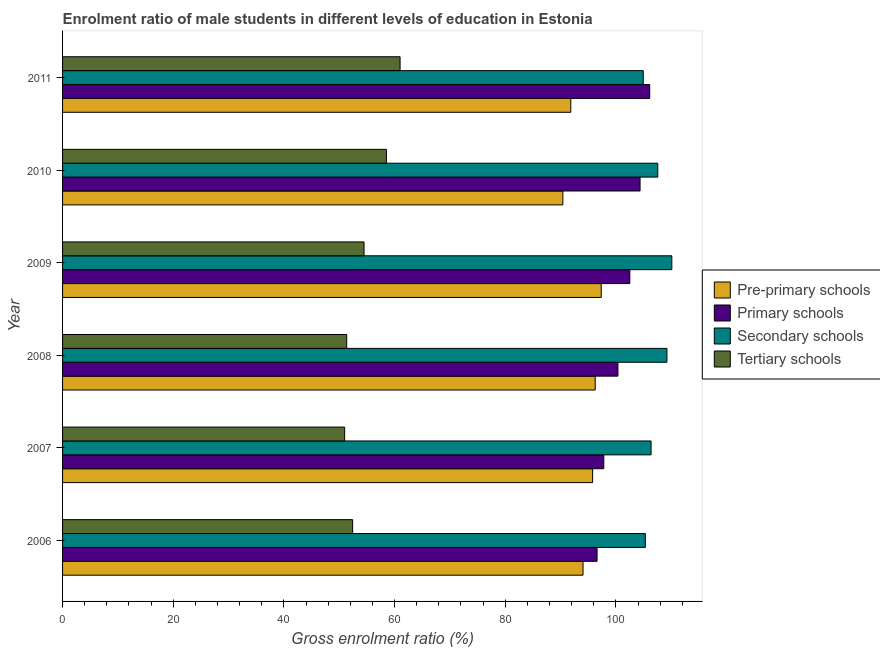How many groups of bars are there?
Provide a short and direct response. 6. Are the number of bars per tick equal to the number of legend labels?
Ensure brevity in your answer.  Yes. Are the number of bars on each tick of the Y-axis equal?
Make the answer very short. Yes. How many bars are there on the 1st tick from the top?
Offer a terse response. 4. What is the label of the 5th group of bars from the top?
Offer a terse response. 2007. What is the gross enrolment ratio(female) in secondary schools in 2007?
Provide a succinct answer. 106.36. Across all years, what is the maximum gross enrolment ratio(female) in secondary schools?
Offer a very short reply. 110.11. Across all years, what is the minimum gross enrolment ratio(female) in pre-primary schools?
Your response must be concise. 90.42. In which year was the gross enrolment ratio(female) in primary schools minimum?
Give a very brief answer. 2006. What is the total gross enrolment ratio(female) in tertiary schools in the graph?
Make the answer very short. 328.78. What is the difference between the gross enrolment ratio(female) in pre-primary schools in 2007 and that in 2011?
Give a very brief answer. 3.95. What is the difference between the gross enrolment ratio(female) in secondary schools in 2011 and the gross enrolment ratio(female) in pre-primary schools in 2008?
Ensure brevity in your answer.  8.69. What is the average gross enrolment ratio(female) in tertiary schools per year?
Make the answer very short. 54.8. In the year 2010, what is the difference between the gross enrolment ratio(female) in tertiary schools and gross enrolment ratio(female) in secondary schools?
Your answer should be very brief. -49.05. In how many years, is the gross enrolment ratio(female) in pre-primary schools greater than 80 %?
Give a very brief answer. 6. What is the ratio of the gross enrolment ratio(female) in primary schools in 2007 to that in 2008?
Your answer should be very brief. 0.97. Is the gross enrolment ratio(female) in secondary schools in 2009 less than that in 2011?
Ensure brevity in your answer.  No. Is the difference between the gross enrolment ratio(female) in primary schools in 2008 and 2009 greater than the difference between the gross enrolment ratio(female) in pre-primary schools in 2008 and 2009?
Provide a succinct answer. No. What is the difference between the highest and the second highest gross enrolment ratio(female) in pre-primary schools?
Keep it short and to the point. 1.09. What is the difference between the highest and the lowest gross enrolment ratio(female) in primary schools?
Give a very brief answer. 9.52. Is the sum of the gross enrolment ratio(female) in tertiary schools in 2006 and 2011 greater than the maximum gross enrolment ratio(female) in primary schools across all years?
Offer a terse response. Yes. What does the 1st bar from the top in 2008 represents?
Your answer should be compact. Tertiary schools. What does the 4th bar from the bottom in 2007 represents?
Ensure brevity in your answer.  Tertiary schools. Is it the case that in every year, the sum of the gross enrolment ratio(female) in pre-primary schools and gross enrolment ratio(female) in primary schools is greater than the gross enrolment ratio(female) in secondary schools?
Provide a short and direct response. Yes. How many bars are there?
Provide a succinct answer. 24. What is the difference between two consecutive major ticks on the X-axis?
Your response must be concise. 20. Are the values on the major ticks of X-axis written in scientific E-notation?
Your answer should be very brief. No. Where does the legend appear in the graph?
Keep it short and to the point. Center right. How many legend labels are there?
Make the answer very short. 4. How are the legend labels stacked?
Offer a very short reply. Vertical. What is the title of the graph?
Your answer should be very brief. Enrolment ratio of male students in different levels of education in Estonia. What is the label or title of the Y-axis?
Your answer should be very brief. Year. What is the Gross enrolment ratio (%) of Pre-primary schools in 2006?
Your answer should be compact. 94.06. What is the Gross enrolment ratio (%) of Primary schools in 2006?
Provide a succinct answer. 96.6. What is the Gross enrolment ratio (%) of Secondary schools in 2006?
Your answer should be compact. 105.33. What is the Gross enrolment ratio (%) of Tertiary schools in 2006?
Make the answer very short. 52.43. What is the Gross enrolment ratio (%) of Pre-primary schools in 2007?
Ensure brevity in your answer.  95.8. What is the Gross enrolment ratio (%) in Primary schools in 2007?
Ensure brevity in your answer.  97.82. What is the Gross enrolment ratio (%) of Secondary schools in 2007?
Keep it short and to the point. 106.36. What is the Gross enrolment ratio (%) in Tertiary schools in 2007?
Keep it short and to the point. 50.98. What is the Gross enrolment ratio (%) in Pre-primary schools in 2008?
Give a very brief answer. 96.26. What is the Gross enrolment ratio (%) in Primary schools in 2008?
Keep it short and to the point. 100.37. What is the Gross enrolment ratio (%) in Secondary schools in 2008?
Offer a very short reply. 109.23. What is the Gross enrolment ratio (%) of Tertiary schools in 2008?
Make the answer very short. 51.35. What is the Gross enrolment ratio (%) of Pre-primary schools in 2009?
Provide a succinct answer. 97.36. What is the Gross enrolment ratio (%) of Primary schools in 2009?
Your answer should be compact. 102.52. What is the Gross enrolment ratio (%) of Secondary schools in 2009?
Give a very brief answer. 110.11. What is the Gross enrolment ratio (%) in Tertiary schools in 2009?
Your answer should be very brief. 54.49. What is the Gross enrolment ratio (%) of Pre-primary schools in 2010?
Your answer should be compact. 90.42. What is the Gross enrolment ratio (%) in Primary schools in 2010?
Ensure brevity in your answer.  104.37. What is the Gross enrolment ratio (%) of Secondary schools in 2010?
Offer a very short reply. 107.58. What is the Gross enrolment ratio (%) of Tertiary schools in 2010?
Offer a terse response. 58.53. What is the Gross enrolment ratio (%) in Pre-primary schools in 2011?
Provide a succinct answer. 91.85. What is the Gross enrolment ratio (%) in Primary schools in 2011?
Your response must be concise. 106.12. What is the Gross enrolment ratio (%) of Secondary schools in 2011?
Give a very brief answer. 104.95. What is the Gross enrolment ratio (%) in Tertiary schools in 2011?
Your answer should be compact. 61. Across all years, what is the maximum Gross enrolment ratio (%) in Pre-primary schools?
Provide a succinct answer. 97.36. Across all years, what is the maximum Gross enrolment ratio (%) of Primary schools?
Provide a short and direct response. 106.12. Across all years, what is the maximum Gross enrolment ratio (%) in Secondary schools?
Your answer should be compact. 110.11. Across all years, what is the maximum Gross enrolment ratio (%) of Tertiary schools?
Your response must be concise. 61. Across all years, what is the minimum Gross enrolment ratio (%) in Pre-primary schools?
Give a very brief answer. 90.42. Across all years, what is the minimum Gross enrolment ratio (%) of Primary schools?
Provide a short and direct response. 96.6. Across all years, what is the minimum Gross enrolment ratio (%) in Secondary schools?
Your answer should be compact. 104.95. Across all years, what is the minimum Gross enrolment ratio (%) of Tertiary schools?
Your answer should be compact. 50.98. What is the total Gross enrolment ratio (%) in Pre-primary schools in the graph?
Provide a short and direct response. 565.75. What is the total Gross enrolment ratio (%) of Primary schools in the graph?
Ensure brevity in your answer.  607.8. What is the total Gross enrolment ratio (%) in Secondary schools in the graph?
Make the answer very short. 643.55. What is the total Gross enrolment ratio (%) of Tertiary schools in the graph?
Provide a short and direct response. 328.78. What is the difference between the Gross enrolment ratio (%) in Pre-primary schools in 2006 and that in 2007?
Make the answer very short. -1.73. What is the difference between the Gross enrolment ratio (%) of Primary schools in 2006 and that in 2007?
Provide a short and direct response. -1.22. What is the difference between the Gross enrolment ratio (%) in Secondary schools in 2006 and that in 2007?
Offer a terse response. -1.03. What is the difference between the Gross enrolment ratio (%) of Tertiary schools in 2006 and that in 2007?
Make the answer very short. 1.44. What is the difference between the Gross enrolment ratio (%) in Pre-primary schools in 2006 and that in 2008?
Make the answer very short. -2.2. What is the difference between the Gross enrolment ratio (%) in Primary schools in 2006 and that in 2008?
Your response must be concise. -3.77. What is the difference between the Gross enrolment ratio (%) in Secondary schools in 2006 and that in 2008?
Your response must be concise. -3.9. What is the difference between the Gross enrolment ratio (%) in Tertiary schools in 2006 and that in 2008?
Keep it short and to the point. 1.07. What is the difference between the Gross enrolment ratio (%) in Pre-primary schools in 2006 and that in 2009?
Ensure brevity in your answer.  -3.29. What is the difference between the Gross enrolment ratio (%) in Primary schools in 2006 and that in 2009?
Ensure brevity in your answer.  -5.92. What is the difference between the Gross enrolment ratio (%) in Secondary schools in 2006 and that in 2009?
Provide a short and direct response. -4.79. What is the difference between the Gross enrolment ratio (%) in Tertiary schools in 2006 and that in 2009?
Your answer should be very brief. -2.06. What is the difference between the Gross enrolment ratio (%) of Pre-primary schools in 2006 and that in 2010?
Ensure brevity in your answer.  3.64. What is the difference between the Gross enrolment ratio (%) in Primary schools in 2006 and that in 2010?
Your response must be concise. -7.77. What is the difference between the Gross enrolment ratio (%) in Secondary schools in 2006 and that in 2010?
Offer a very short reply. -2.25. What is the difference between the Gross enrolment ratio (%) of Tertiary schools in 2006 and that in 2010?
Your answer should be compact. -6.1. What is the difference between the Gross enrolment ratio (%) in Pre-primary schools in 2006 and that in 2011?
Ensure brevity in your answer.  2.21. What is the difference between the Gross enrolment ratio (%) in Primary schools in 2006 and that in 2011?
Offer a terse response. -9.52. What is the difference between the Gross enrolment ratio (%) of Secondary schools in 2006 and that in 2011?
Offer a terse response. 0.38. What is the difference between the Gross enrolment ratio (%) in Tertiary schools in 2006 and that in 2011?
Your response must be concise. -8.57. What is the difference between the Gross enrolment ratio (%) of Pre-primary schools in 2007 and that in 2008?
Offer a terse response. -0.47. What is the difference between the Gross enrolment ratio (%) in Primary schools in 2007 and that in 2008?
Ensure brevity in your answer.  -2.56. What is the difference between the Gross enrolment ratio (%) of Secondary schools in 2007 and that in 2008?
Make the answer very short. -2.87. What is the difference between the Gross enrolment ratio (%) in Tertiary schools in 2007 and that in 2008?
Provide a short and direct response. -0.37. What is the difference between the Gross enrolment ratio (%) of Pre-primary schools in 2007 and that in 2009?
Ensure brevity in your answer.  -1.56. What is the difference between the Gross enrolment ratio (%) in Primary schools in 2007 and that in 2009?
Offer a very short reply. -4.7. What is the difference between the Gross enrolment ratio (%) of Secondary schools in 2007 and that in 2009?
Keep it short and to the point. -3.75. What is the difference between the Gross enrolment ratio (%) in Tertiary schools in 2007 and that in 2009?
Offer a terse response. -3.5. What is the difference between the Gross enrolment ratio (%) of Pre-primary schools in 2007 and that in 2010?
Provide a succinct answer. 5.37. What is the difference between the Gross enrolment ratio (%) in Primary schools in 2007 and that in 2010?
Ensure brevity in your answer.  -6.55. What is the difference between the Gross enrolment ratio (%) of Secondary schools in 2007 and that in 2010?
Your answer should be compact. -1.22. What is the difference between the Gross enrolment ratio (%) in Tertiary schools in 2007 and that in 2010?
Your response must be concise. -7.55. What is the difference between the Gross enrolment ratio (%) of Pre-primary schools in 2007 and that in 2011?
Keep it short and to the point. 3.95. What is the difference between the Gross enrolment ratio (%) in Primary schools in 2007 and that in 2011?
Give a very brief answer. -8.3. What is the difference between the Gross enrolment ratio (%) of Secondary schools in 2007 and that in 2011?
Your answer should be very brief. 1.41. What is the difference between the Gross enrolment ratio (%) in Tertiary schools in 2007 and that in 2011?
Provide a succinct answer. -10.02. What is the difference between the Gross enrolment ratio (%) in Pre-primary schools in 2008 and that in 2009?
Offer a terse response. -1.09. What is the difference between the Gross enrolment ratio (%) of Primary schools in 2008 and that in 2009?
Provide a succinct answer. -2.15. What is the difference between the Gross enrolment ratio (%) of Secondary schools in 2008 and that in 2009?
Offer a terse response. -0.88. What is the difference between the Gross enrolment ratio (%) of Tertiary schools in 2008 and that in 2009?
Provide a succinct answer. -3.13. What is the difference between the Gross enrolment ratio (%) of Pre-primary schools in 2008 and that in 2010?
Provide a short and direct response. 5.84. What is the difference between the Gross enrolment ratio (%) of Primary schools in 2008 and that in 2010?
Provide a short and direct response. -4. What is the difference between the Gross enrolment ratio (%) in Secondary schools in 2008 and that in 2010?
Your answer should be very brief. 1.65. What is the difference between the Gross enrolment ratio (%) in Tertiary schools in 2008 and that in 2010?
Provide a short and direct response. -7.18. What is the difference between the Gross enrolment ratio (%) of Pre-primary schools in 2008 and that in 2011?
Keep it short and to the point. 4.41. What is the difference between the Gross enrolment ratio (%) in Primary schools in 2008 and that in 2011?
Keep it short and to the point. -5.74. What is the difference between the Gross enrolment ratio (%) in Secondary schools in 2008 and that in 2011?
Keep it short and to the point. 4.28. What is the difference between the Gross enrolment ratio (%) in Tertiary schools in 2008 and that in 2011?
Keep it short and to the point. -9.65. What is the difference between the Gross enrolment ratio (%) of Pre-primary schools in 2009 and that in 2010?
Offer a terse response. 6.93. What is the difference between the Gross enrolment ratio (%) of Primary schools in 2009 and that in 2010?
Give a very brief answer. -1.85. What is the difference between the Gross enrolment ratio (%) of Secondary schools in 2009 and that in 2010?
Give a very brief answer. 2.54. What is the difference between the Gross enrolment ratio (%) in Tertiary schools in 2009 and that in 2010?
Provide a short and direct response. -4.04. What is the difference between the Gross enrolment ratio (%) of Pre-primary schools in 2009 and that in 2011?
Keep it short and to the point. 5.5. What is the difference between the Gross enrolment ratio (%) of Primary schools in 2009 and that in 2011?
Your response must be concise. -3.6. What is the difference between the Gross enrolment ratio (%) in Secondary schools in 2009 and that in 2011?
Your answer should be very brief. 5.16. What is the difference between the Gross enrolment ratio (%) of Tertiary schools in 2009 and that in 2011?
Offer a terse response. -6.51. What is the difference between the Gross enrolment ratio (%) of Pre-primary schools in 2010 and that in 2011?
Offer a very short reply. -1.43. What is the difference between the Gross enrolment ratio (%) in Primary schools in 2010 and that in 2011?
Offer a very short reply. -1.74. What is the difference between the Gross enrolment ratio (%) in Secondary schools in 2010 and that in 2011?
Make the answer very short. 2.63. What is the difference between the Gross enrolment ratio (%) in Tertiary schools in 2010 and that in 2011?
Provide a succinct answer. -2.47. What is the difference between the Gross enrolment ratio (%) in Pre-primary schools in 2006 and the Gross enrolment ratio (%) in Primary schools in 2007?
Provide a succinct answer. -3.75. What is the difference between the Gross enrolment ratio (%) in Pre-primary schools in 2006 and the Gross enrolment ratio (%) in Secondary schools in 2007?
Provide a short and direct response. -12.3. What is the difference between the Gross enrolment ratio (%) of Pre-primary schools in 2006 and the Gross enrolment ratio (%) of Tertiary schools in 2007?
Your response must be concise. 43.08. What is the difference between the Gross enrolment ratio (%) in Primary schools in 2006 and the Gross enrolment ratio (%) in Secondary schools in 2007?
Provide a succinct answer. -9.76. What is the difference between the Gross enrolment ratio (%) of Primary schools in 2006 and the Gross enrolment ratio (%) of Tertiary schools in 2007?
Provide a succinct answer. 45.62. What is the difference between the Gross enrolment ratio (%) of Secondary schools in 2006 and the Gross enrolment ratio (%) of Tertiary schools in 2007?
Your answer should be very brief. 54.34. What is the difference between the Gross enrolment ratio (%) in Pre-primary schools in 2006 and the Gross enrolment ratio (%) in Primary schools in 2008?
Provide a succinct answer. -6.31. What is the difference between the Gross enrolment ratio (%) of Pre-primary schools in 2006 and the Gross enrolment ratio (%) of Secondary schools in 2008?
Keep it short and to the point. -15.17. What is the difference between the Gross enrolment ratio (%) of Pre-primary schools in 2006 and the Gross enrolment ratio (%) of Tertiary schools in 2008?
Offer a terse response. 42.71. What is the difference between the Gross enrolment ratio (%) in Primary schools in 2006 and the Gross enrolment ratio (%) in Secondary schools in 2008?
Make the answer very short. -12.63. What is the difference between the Gross enrolment ratio (%) in Primary schools in 2006 and the Gross enrolment ratio (%) in Tertiary schools in 2008?
Keep it short and to the point. 45.25. What is the difference between the Gross enrolment ratio (%) in Secondary schools in 2006 and the Gross enrolment ratio (%) in Tertiary schools in 2008?
Provide a succinct answer. 53.97. What is the difference between the Gross enrolment ratio (%) of Pre-primary schools in 2006 and the Gross enrolment ratio (%) of Primary schools in 2009?
Your answer should be compact. -8.46. What is the difference between the Gross enrolment ratio (%) of Pre-primary schools in 2006 and the Gross enrolment ratio (%) of Secondary schools in 2009?
Your response must be concise. -16.05. What is the difference between the Gross enrolment ratio (%) of Pre-primary schools in 2006 and the Gross enrolment ratio (%) of Tertiary schools in 2009?
Keep it short and to the point. 39.58. What is the difference between the Gross enrolment ratio (%) of Primary schools in 2006 and the Gross enrolment ratio (%) of Secondary schools in 2009?
Provide a short and direct response. -13.51. What is the difference between the Gross enrolment ratio (%) in Primary schools in 2006 and the Gross enrolment ratio (%) in Tertiary schools in 2009?
Make the answer very short. 42.11. What is the difference between the Gross enrolment ratio (%) in Secondary schools in 2006 and the Gross enrolment ratio (%) in Tertiary schools in 2009?
Offer a terse response. 50.84. What is the difference between the Gross enrolment ratio (%) of Pre-primary schools in 2006 and the Gross enrolment ratio (%) of Primary schools in 2010?
Your response must be concise. -10.31. What is the difference between the Gross enrolment ratio (%) of Pre-primary schools in 2006 and the Gross enrolment ratio (%) of Secondary schools in 2010?
Provide a short and direct response. -13.51. What is the difference between the Gross enrolment ratio (%) of Pre-primary schools in 2006 and the Gross enrolment ratio (%) of Tertiary schools in 2010?
Keep it short and to the point. 35.53. What is the difference between the Gross enrolment ratio (%) in Primary schools in 2006 and the Gross enrolment ratio (%) in Secondary schools in 2010?
Your answer should be very brief. -10.98. What is the difference between the Gross enrolment ratio (%) in Primary schools in 2006 and the Gross enrolment ratio (%) in Tertiary schools in 2010?
Your response must be concise. 38.07. What is the difference between the Gross enrolment ratio (%) of Secondary schools in 2006 and the Gross enrolment ratio (%) of Tertiary schools in 2010?
Offer a terse response. 46.79. What is the difference between the Gross enrolment ratio (%) in Pre-primary schools in 2006 and the Gross enrolment ratio (%) in Primary schools in 2011?
Your answer should be very brief. -12.05. What is the difference between the Gross enrolment ratio (%) in Pre-primary schools in 2006 and the Gross enrolment ratio (%) in Secondary schools in 2011?
Offer a very short reply. -10.88. What is the difference between the Gross enrolment ratio (%) of Pre-primary schools in 2006 and the Gross enrolment ratio (%) of Tertiary schools in 2011?
Provide a short and direct response. 33.06. What is the difference between the Gross enrolment ratio (%) in Primary schools in 2006 and the Gross enrolment ratio (%) in Secondary schools in 2011?
Offer a terse response. -8.35. What is the difference between the Gross enrolment ratio (%) in Primary schools in 2006 and the Gross enrolment ratio (%) in Tertiary schools in 2011?
Your response must be concise. 35.6. What is the difference between the Gross enrolment ratio (%) in Secondary schools in 2006 and the Gross enrolment ratio (%) in Tertiary schools in 2011?
Keep it short and to the point. 44.33. What is the difference between the Gross enrolment ratio (%) of Pre-primary schools in 2007 and the Gross enrolment ratio (%) of Primary schools in 2008?
Offer a very short reply. -4.58. What is the difference between the Gross enrolment ratio (%) in Pre-primary schools in 2007 and the Gross enrolment ratio (%) in Secondary schools in 2008?
Your answer should be compact. -13.43. What is the difference between the Gross enrolment ratio (%) in Pre-primary schools in 2007 and the Gross enrolment ratio (%) in Tertiary schools in 2008?
Your response must be concise. 44.45. What is the difference between the Gross enrolment ratio (%) of Primary schools in 2007 and the Gross enrolment ratio (%) of Secondary schools in 2008?
Offer a terse response. -11.41. What is the difference between the Gross enrolment ratio (%) in Primary schools in 2007 and the Gross enrolment ratio (%) in Tertiary schools in 2008?
Make the answer very short. 46.46. What is the difference between the Gross enrolment ratio (%) in Secondary schools in 2007 and the Gross enrolment ratio (%) in Tertiary schools in 2008?
Keep it short and to the point. 55.01. What is the difference between the Gross enrolment ratio (%) in Pre-primary schools in 2007 and the Gross enrolment ratio (%) in Primary schools in 2009?
Give a very brief answer. -6.72. What is the difference between the Gross enrolment ratio (%) in Pre-primary schools in 2007 and the Gross enrolment ratio (%) in Secondary schools in 2009?
Make the answer very short. -14.31. What is the difference between the Gross enrolment ratio (%) in Pre-primary schools in 2007 and the Gross enrolment ratio (%) in Tertiary schools in 2009?
Provide a succinct answer. 41.31. What is the difference between the Gross enrolment ratio (%) of Primary schools in 2007 and the Gross enrolment ratio (%) of Secondary schools in 2009?
Give a very brief answer. -12.3. What is the difference between the Gross enrolment ratio (%) in Primary schools in 2007 and the Gross enrolment ratio (%) in Tertiary schools in 2009?
Provide a succinct answer. 43.33. What is the difference between the Gross enrolment ratio (%) in Secondary schools in 2007 and the Gross enrolment ratio (%) in Tertiary schools in 2009?
Offer a terse response. 51.87. What is the difference between the Gross enrolment ratio (%) of Pre-primary schools in 2007 and the Gross enrolment ratio (%) of Primary schools in 2010?
Your answer should be very brief. -8.57. What is the difference between the Gross enrolment ratio (%) of Pre-primary schools in 2007 and the Gross enrolment ratio (%) of Secondary schools in 2010?
Give a very brief answer. -11.78. What is the difference between the Gross enrolment ratio (%) in Pre-primary schools in 2007 and the Gross enrolment ratio (%) in Tertiary schools in 2010?
Offer a terse response. 37.27. What is the difference between the Gross enrolment ratio (%) in Primary schools in 2007 and the Gross enrolment ratio (%) in Secondary schools in 2010?
Provide a succinct answer. -9.76. What is the difference between the Gross enrolment ratio (%) in Primary schools in 2007 and the Gross enrolment ratio (%) in Tertiary schools in 2010?
Your response must be concise. 39.29. What is the difference between the Gross enrolment ratio (%) in Secondary schools in 2007 and the Gross enrolment ratio (%) in Tertiary schools in 2010?
Make the answer very short. 47.83. What is the difference between the Gross enrolment ratio (%) in Pre-primary schools in 2007 and the Gross enrolment ratio (%) in Primary schools in 2011?
Make the answer very short. -10.32. What is the difference between the Gross enrolment ratio (%) of Pre-primary schools in 2007 and the Gross enrolment ratio (%) of Secondary schools in 2011?
Your response must be concise. -9.15. What is the difference between the Gross enrolment ratio (%) of Pre-primary schools in 2007 and the Gross enrolment ratio (%) of Tertiary schools in 2011?
Provide a short and direct response. 34.8. What is the difference between the Gross enrolment ratio (%) of Primary schools in 2007 and the Gross enrolment ratio (%) of Secondary schools in 2011?
Give a very brief answer. -7.13. What is the difference between the Gross enrolment ratio (%) in Primary schools in 2007 and the Gross enrolment ratio (%) in Tertiary schools in 2011?
Provide a succinct answer. 36.82. What is the difference between the Gross enrolment ratio (%) in Secondary schools in 2007 and the Gross enrolment ratio (%) in Tertiary schools in 2011?
Your answer should be compact. 45.36. What is the difference between the Gross enrolment ratio (%) of Pre-primary schools in 2008 and the Gross enrolment ratio (%) of Primary schools in 2009?
Your answer should be very brief. -6.26. What is the difference between the Gross enrolment ratio (%) of Pre-primary schools in 2008 and the Gross enrolment ratio (%) of Secondary schools in 2009?
Provide a short and direct response. -13.85. What is the difference between the Gross enrolment ratio (%) of Pre-primary schools in 2008 and the Gross enrolment ratio (%) of Tertiary schools in 2009?
Ensure brevity in your answer.  41.78. What is the difference between the Gross enrolment ratio (%) in Primary schools in 2008 and the Gross enrolment ratio (%) in Secondary schools in 2009?
Provide a short and direct response. -9.74. What is the difference between the Gross enrolment ratio (%) of Primary schools in 2008 and the Gross enrolment ratio (%) of Tertiary schools in 2009?
Offer a terse response. 45.89. What is the difference between the Gross enrolment ratio (%) of Secondary schools in 2008 and the Gross enrolment ratio (%) of Tertiary schools in 2009?
Offer a very short reply. 54.74. What is the difference between the Gross enrolment ratio (%) of Pre-primary schools in 2008 and the Gross enrolment ratio (%) of Primary schools in 2010?
Ensure brevity in your answer.  -8.11. What is the difference between the Gross enrolment ratio (%) in Pre-primary schools in 2008 and the Gross enrolment ratio (%) in Secondary schools in 2010?
Your answer should be compact. -11.31. What is the difference between the Gross enrolment ratio (%) of Pre-primary schools in 2008 and the Gross enrolment ratio (%) of Tertiary schools in 2010?
Offer a terse response. 37.73. What is the difference between the Gross enrolment ratio (%) of Primary schools in 2008 and the Gross enrolment ratio (%) of Secondary schools in 2010?
Make the answer very short. -7.2. What is the difference between the Gross enrolment ratio (%) of Primary schools in 2008 and the Gross enrolment ratio (%) of Tertiary schools in 2010?
Ensure brevity in your answer.  41.84. What is the difference between the Gross enrolment ratio (%) of Secondary schools in 2008 and the Gross enrolment ratio (%) of Tertiary schools in 2010?
Make the answer very short. 50.7. What is the difference between the Gross enrolment ratio (%) in Pre-primary schools in 2008 and the Gross enrolment ratio (%) in Primary schools in 2011?
Offer a very short reply. -9.85. What is the difference between the Gross enrolment ratio (%) of Pre-primary schools in 2008 and the Gross enrolment ratio (%) of Secondary schools in 2011?
Make the answer very short. -8.69. What is the difference between the Gross enrolment ratio (%) of Pre-primary schools in 2008 and the Gross enrolment ratio (%) of Tertiary schools in 2011?
Provide a succinct answer. 35.26. What is the difference between the Gross enrolment ratio (%) of Primary schools in 2008 and the Gross enrolment ratio (%) of Secondary schools in 2011?
Give a very brief answer. -4.58. What is the difference between the Gross enrolment ratio (%) in Primary schools in 2008 and the Gross enrolment ratio (%) in Tertiary schools in 2011?
Ensure brevity in your answer.  39.37. What is the difference between the Gross enrolment ratio (%) of Secondary schools in 2008 and the Gross enrolment ratio (%) of Tertiary schools in 2011?
Make the answer very short. 48.23. What is the difference between the Gross enrolment ratio (%) of Pre-primary schools in 2009 and the Gross enrolment ratio (%) of Primary schools in 2010?
Provide a succinct answer. -7.02. What is the difference between the Gross enrolment ratio (%) in Pre-primary schools in 2009 and the Gross enrolment ratio (%) in Secondary schools in 2010?
Offer a very short reply. -10.22. What is the difference between the Gross enrolment ratio (%) in Pre-primary schools in 2009 and the Gross enrolment ratio (%) in Tertiary schools in 2010?
Make the answer very short. 38.82. What is the difference between the Gross enrolment ratio (%) of Primary schools in 2009 and the Gross enrolment ratio (%) of Secondary schools in 2010?
Provide a succinct answer. -5.06. What is the difference between the Gross enrolment ratio (%) of Primary schools in 2009 and the Gross enrolment ratio (%) of Tertiary schools in 2010?
Offer a terse response. 43.99. What is the difference between the Gross enrolment ratio (%) in Secondary schools in 2009 and the Gross enrolment ratio (%) in Tertiary schools in 2010?
Provide a succinct answer. 51.58. What is the difference between the Gross enrolment ratio (%) of Pre-primary schools in 2009 and the Gross enrolment ratio (%) of Primary schools in 2011?
Provide a short and direct response. -8.76. What is the difference between the Gross enrolment ratio (%) in Pre-primary schools in 2009 and the Gross enrolment ratio (%) in Secondary schools in 2011?
Make the answer very short. -7.59. What is the difference between the Gross enrolment ratio (%) of Pre-primary schools in 2009 and the Gross enrolment ratio (%) of Tertiary schools in 2011?
Your answer should be compact. 36.35. What is the difference between the Gross enrolment ratio (%) of Primary schools in 2009 and the Gross enrolment ratio (%) of Secondary schools in 2011?
Make the answer very short. -2.43. What is the difference between the Gross enrolment ratio (%) of Primary schools in 2009 and the Gross enrolment ratio (%) of Tertiary schools in 2011?
Your answer should be compact. 41.52. What is the difference between the Gross enrolment ratio (%) of Secondary schools in 2009 and the Gross enrolment ratio (%) of Tertiary schools in 2011?
Your answer should be very brief. 49.11. What is the difference between the Gross enrolment ratio (%) in Pre-primary schools in 2010 and the Gross enrolment ratio (%) in Primary schools in 2011?
Keep it short and to the point. -15.69. What is the difference between the Gross enrolment ratio (%) in Pre-primary schools in 2010 and the Gross enrolment ratio (%) in Secondary schools in 2011?
Your answer should be very brief. -14.53. What is the difference between the Gross enrolment ratio (%) of Pre-primary schools in 2010 and the Gross enrolment ratio (%) of Tertiary schools in 2011?
Your answer should be compact. 29.42. What is the difference between the Gross enrolment ratio (%) in Primary schools in 2010 and the Gross enrolment ratio (%) in Secondary schools in 2011?
Make the answer very short. -0.58. What is the difference between the Gross enrolment ratio (%) of Primary schools in 2010 and the Gross enrolment ratio (%) of Tertiary schools in 2011?
Offer a very short reply. 43.37. What is the difference between the Gross enrolment ratio (%) in Secondary schools in 2010 and the Gross enrolment ratio (%) in Tertiary schools in 2011?
Provide a succinct answer. 46.58. What is the average Gross enrolment ratio (%) in Pre-primary schools per year?
Your response must be concise. 94.29. What is the average Gross enrolment ratio (%) in Primary schools per year?
Offer a terse response. 101.3. What is the average Gross enrolment ratio (%) of Secondary schools per year?
Provide a short and direct response. 107.26. What is the average Gross enrolment ratio (%) in Tertiary schools per year?
Your answer should be very brief. 54.8. In the year 2006, what is the difference between the Gross enrolment ratio (%) in Pre-primary schools and Gross enrolment ratio (%) in Primary schools?
Offer a very short reply. -2.54. In the year 2006, what is the difference between the Gross enrolment ratio (%) of Pre-primary schools and Gross enrolment ratio (%) of Secondary schools?
Keep it short and to the point. -11.26. In the year 2006, what is the difference between the Gross enrolment ratio (%) in Pre-primary schools and Gross enrolment ratio (%) in Tertiary schools?
Your answer should be compact. 41.64. In the year 2006, what is the difference between the Gross enrolment ratio (%) in Primary schools and Gross enrolment ratio (%) in Secondary schools?
Provide a succinct answer. -8.73. In the year 2006, what is the difference between the Gross enrolment ratio (%) of Primary schools and Gross enrolment ratio (%) of Tertiary schools?
Your response must be concise. 44.17. In the year 2006, what is the difference between the Gross enrolment ratio (%) of Secondary schools and Gross enrolment ratio (%) of Tertiary schools?
Keep it short and to the point. 52.9. In the year 2007, what is the difference between the Gross enrolment ratio (%) of Pre-primary schools and Gross enrolment ratio (%) of Primary schools?
Give a very brief answer. -2.02. In the year 2007, what is the difference between the Gross enrolment ratio (%) of Pre-primary schools and Gross enrolment ratio (%) of Secondary schools?
Your response must be concise. -10.56. In the year 2007, what is the difference between the Gross enrolment ratio (%) in Pre-primary schools and Gross enrolment ratio (%) in Tertiary schools?
Ensure brevity in your answer.  44.81. In the year 2007, what is the difference between the Gross enrolment ratio (%) in Primary schools and Gross enrolment ratio (%) in Secondary schools?
Ensure brevity in your answer.  -8.54. In the year 2007, what is the difference between the Gross enrolment ratio (%) of Primary schools and Gross enrolment ratio (%) of Tertiary schools?
Offer a very short reply. 46.83. In the year 2007, what is the difference between the Gross enrolment ratio (%) in Secondary schools and Gross enrolment ratio (%) in Tertiary schools?
Your response must be concise. 55.38. In the year 2008, what is the difference between the Gross enrolment ratio (%) in Pre-primary schools and Gross enrolment ratio (%) in Primary schools?
Your answer should be compact. -4.11. In the year 2008, what is the difference between the Gross enrolment ratio (%) in Pre-primary schools and Gross enrolment ratio (%) in Secondary schools?
Your response must be concise. -12.97. In the year 2008, what is the difference between the Gross enrolment ratio (%) in Pre-primary schools and Gross enrolment ratio (%) in Tertiary schools?
Ensure brevity in your answer.  44.91. In the year 2008, what is the difference between the Gross enrolment ratio (%) of Primary schools and Gross enrolment ratio (%) of Secondary schools?
Give a very brief answer. -8.86. In the year 2008, what is the difference between the Gross enrolment ratio (%) of Primary schools and Gross enrolment ratio (%) of Tertiary schools?
Keep it short and to the point. 49.02. In the year 2008, what is the difference between the Gross enrolment ratio (%) of Secondary schools and Gross enrolment ratio (%) of Tertiary schools?
Your response must be concise. 57.88. In the year 2009, what is the difference between the Gross enrolment ratio (%) in Pre-primary schools and Gross enrolment ratio (%) in Primary schools?
Offer a very short reply. -5.17. In the year 2009, what is the difference between the Gross enrolment ratio (%) in Pre-primary schools and Gross enrolment ratio (%) in Secondary schools?
Your response must be concise. -12.76. In the year 2009, what is the difference between the Gross enrolment ratio (%) in Pre-primary schools and Gross enrolment ratio (%) in Tertiary schools?
Ensure brevity in your answer.  42.87. In the year 2009, what is the difference between the Gross enrolment ratio (%) in Primary schools and Gross enrolment ratio (%) in Secondary schools?
Offer a terse response. -7.59. In the year 2009, what is the difference between the Gross enrolment ratio (%) in Primary schools and Gross enrolment ratio (%) in Tertiary schools?
Give a very brief answer. 48.03. In the year 2009, what is the difference between the Gross enrolment ratio (%) of Secondary schools and Gross enrolment ratio (%) of Tertiary schools?
Make the answer very short. 55.63. In the year 2010, what is the difference between the Gross enrolment ratio (%) in Pre-primary schools and Gross enrolment ratio (%) in Primary schools?
Your answer should be compact. -13.95. In the year 2010, what is the difference between the Gross enrolment ratio (%) in Pre-primary schools and Gross enrolment ratio (%) in Secondary schools?
Keep it short and to the point. -17.15. In the year 2010, what is the difference between the Gross enrolment ratio (%) of Pre-primary schools and Gross enrolment ratio (%) of Tertiary schools?
Ensure brevity in your answer.  31.89. In the year 2010, what is the difference between the Gross enrolment ratio (%) of Primary schools and Gross enrolment ratio (%) of Secondary schools?
Ensure brevity in your answer.  -3.21. In the year 2010, what is the difference between the Gross enrolment ratio (%) of Primary schools and Gross enrolment ratio (%) of Tertiary schools?
Ensure brevity in your answer.  45.84. In the year 2010, what is the difference between the Gross enrolment ratio (%) in Secondary schools and Gross enrolment ratio (%) in Tertiary schools?
Your response must be concise. 49.05. In the year 2011, what is the difference between the Gross enrolment ratio (%) of Pre-primary schools and Gross enrolment ratio (%) of Primary schools?
Provide a succinct answer. -14.27. In the year 2011, what is the difference between the Gross enrolment ratio (%) of Pre-primary schools and Gross enrolment ratio (%) of Secondary schools?
Provide a short and direct response. -13.1. In the year 2011, what is the difference between the Gross enrolment ratio (%) of Pre-primary schools and Gross enrolment ratio (%) of Tertiary schools?
Provide a short and direct response. 30.85. In the year 2011, what is the difference between the Gross enrolment ratio (%) of Primary schools and Gross enrolment ratio (%) of Secondary schools?
Ensure brevity in your answer.  1.17. In the year 2011, what is the difference between the Gross enrolment ratio (%) in Primary schools and Gross enrolment ratio (%) in Tertiary schools?
Your answer should be compact. 45.12. In the year 2011, what is the difference between the Gross enrolment ratio (%) in Secondary schools and Gross enrolment ratio (%) in Tertiary schools?
Keep it short and to the point. 43.95. What is the ratio of the Gross enrolment ratio (%) of Pre-primary schools in 2006 to that in 2007?
Offer a very short reply. 0.98. What is the ratio of the Gross enrolment ratio (%) in Primary schools in 2006 to that in 2007?
Offer a very short reply. 0.99. What is the ratio of the Gross enrolment ratio (%) of Secondary schools in 2006 to that in 2007?
Keep it short and to the point. 0.99. What is the ratio of the Gross enrolment ratio (%) in Tertiary schools in 2006 to that in 2007?
Give a very brief answer. 1.03. What is the ratio of the Gross enrolment ratio (%) of Pre-primary schools in 2006 to that in 2008?
Offer a very short reply. 0.98. What is the ratio of the Gross enrolment ratio (%) in Primary schools in 2006 to that in 2008?
Give a very brief answer. 0.96. What is the ratio of the Gross enrolment ratio (%) of Secondary schools in 2006 to that in 2008?
Your answer should be compact. 0.96. What is the ratio of the Gross enrolment ratio (%) of Tertiary schools in 2006 to that in 2008?
Provide a succinct answer. 1.02. What is the ratio of the Gross enrolment ratio (%) in Pre-primary schools in 2006 to that in 2009?
Your response must be concise. 0.97. What is the ratio of the Gross enrolment ratio (%) of Primary schools in 2006 to that in 2009?
Ensure brevity in your answer.  0.94. What is the ratio of the Gross enrolment ratio (%) of Secondary schools in 2006 to that in 2009?
Make the answer very short. 0.96. What is the ratio of the Gross enrolment ratio (%) of Tertiary schools in 2006 to that in 2009?
Offer a terse response. 0.96. What is the ratio of the Gross enrolment ratio (%) in Pre-primary schools in 2006 to that in 2010?
Offer a very short reply. 1.04. What is the ratio of the Gross enrolment ratio (%) of Primary schools in 2006 to that in 2010?
Your answer should be very brief. 0.93. What is the ratio of the Gross enrolment ratio (%) of Secondary schools in 2006 to that in 2010?
Keep it short and to the point. 0.98. What is the ratio of the Gross enrolment ratio (%) in Tertiary schools in 2006 to that in 2010?
Ensure brevity in your answer.  0.9. What is the ratio of the Gross enrolment ratio (%) in Pre-primary schools in 2006 to that in 2011?
Offer a very short reply. 1.02. What is the ratio of the Gross enrolment ratio (%) in Primary schools in 2006 to that in 2011?
Give a very brief answer. 0.91. What is the ratio of the Gross enrolment ratio (%) in Tertiary schools in 2006 to that in 2011?
Offer a terse response. 0.86. What is the ratio of the Gross enrolment ratio (%) of Pre-primary schools in 2007 to that in 2008?
Ensure brevity in your answer.  1. What is the ratio of the Gross enrolment ratio (%) in Primary schools in 2007 to that in 2008?
Your answer should be compact. 0.97. What is the ratio of the Gross enrolment ratio (%) in Secondary schools in 2007 to that in 2008?
Your response must be concise. 0.97. What is the ratio of the Gross enrolment ratio (%) of Pre-primary schools in 2007 to that in 2009?
Provide a succinct answer. 0.98. What is the ratio of the Gross enrolment ratio (%) of Primary schools in 2007 to that in 2009?
Your response must be concise. 0.95. What is the ratio of the Gross enrolment ratio (%) of Secondary schools in 2007 to that in 2009?
Provide a short and direct response. 0.97. What is the ratio of the Gross enrolment ratio (%) in Tertiary schools in 2007 to that in 2009?
Keep it short and to the point. 0.94. What is the ratio of the Gross enrolment ratio (%) of Pre-primary schools in 2007 to that in 2010?
Your answer should be very brief. 1.06. What is the ratio of the Gross enrolment ratio (%) in Primary schools in 2007 to that in 2010?
Ensure brevity in your answer.  0.94. What is the ratio of the Gross enrolment ratio (%) in Secondary schools in 2007 to that in 2010?
Your response must be concise. 0.99. What is the ratio of the Gross enrolment ratio (%) in Tertiary schools in 2007 to that in 2010?
Offer a terse response. 0.87. What is the ratio of the Gross enrolment ratio (%) in Pre-primary schools in 2007 to that in 2011?
Make the answer very short. 1.04. What is the ratio of the Gross enrolment ratio (%) of Primary schools in 2007 to that in 2011?
Keep it short and to the point. 0.92. What is the ratio of the Gross enrolment ratio (%) in Secondary schools in 2007 to that in 2011?
Ensure brevity in your answer.  1.01. What is the ratio of the Gross enrolment ratio (%) in Tertiary schools in 2007 to that in 2011?
Your answer should be very brief. 0.84. What is the ratio of the Gross enrolment ratio (%) of Primary schools in 2008 to that in 2009?
Keep it short and to the point. 0.98. What is the ratio of the Gross enrolment ratio (%) of Secondary schools in 2008 to that in 2009?
Your answer should be compact. 0.99. What is the ratio of the Gross enrolment ratio (%) in Tertiary schools in 2008 to that in 2009?
Your response must be concise. 0.94. What is the ratio of the Gross enrolment ratio (%) in Pre-primary schools in 2008 to that in 2010?
Offer a very short reply. 1.06. What is the ratio of the Gross enrolment ratio (%) in Primary schools in 2008 to that in 2010?
Your answer should be compact. 0.96. What is the ratio of the Gross enrolment ratio (%) in Secondary schools in 2008 to that in 2010?
Offer a very short reply. 1.02. What is the ratio of the Gross enrolment ratio (%) of Tertiary schools in 2008 to that in 2010?
Offer a terse response. 0.88. What is the ratio of the Gross enrolment ratio (%) of Pre-primary schools in 2008 to that in 2011?
Provide a short and direct response. 1.05. What is the ratio of the Gross enrolment ratio (%) in Primary schools in 2008 to that in 2011?
Provide a succinct answer. 0.95. What is the ratio of the Gross enrolment ratio (%) in Secondary schools in 2008 to that in 2011?
Keep it short and to the point. 1.04. What is the ratio of the Gross enrolment ratio (%) in Tertiary schools in 2008 to that in 2011?
Offer a very short reply. 0.84. What is the ratio of the Gross enrolment ratio (%) of Pre-primary schools in 2009 to that in 2010?
Give a very brief answer. 1.08. What is the ratio of the Gross enrolment ratio (%) in Primary schools in 2009 to that in 2010?
Your answer should be compact. 0.98. What is the ratio of the Gross enrolment ratio (%) of Secondary schools in 2009 to that in 2010?
Keep it short and to the point. 1.02. What is the ratio of the Gross enrolment ratio (%) in Tertiary schools in 2009 to that in 2010?
Provide a succinct answer. 0.93. What is the ratio of the Gross enrolment ratio (%) of Pre-primary schools in 2009 to that in 2011?
Ensure brevity in your answer.  1.06. What is the ratio of the Gross enrolment ratio (%) in Primary schools in 2009 to that in 2011?
Your answer should be very brief. 0.97. What is the ratio of the Gross enrolment ratio (%) of Secondary schools in 2009 to that in 2011?
Your answer should be compact. 1.05. What is the ratio of the Gross enrolment ratio (%) of Tertiary schools in 2009 to that in 2011?
Provide a succinct answer. 0.89. What is the ratio of the Gross enrolment ratio (%) of Pre-primary schools in 2010 to that in 2011?
Keep it short and to the point. 0.98. What is the ratio of the Gross enrolment ratio (%) in Primary schools in 2010 to that in 2011?
Keep it short and to the point. 0.98. What is the ratio of the Gross enrolment ratio (%) of Tertiary schools in 2010 to that in 2011?
Offer a very short reply. 0.96. What is the difference between the highest and the second highest Gross enrolment ratio (%) in Pre-primary schools?
Keep it short and to the point. 1.09. What is the difference between the highest and the second highest Gross enrolment ratio (%) of Primary schools?
Offer a terse response. 1.74. What is the difference between the highest and the second highest Gross enrolment ratio (%) of Secondary schools?
Your response must be concise. 0.88. What is the difference between the highest and the second highest Gross enrolment ratio (%) in Tertiary schools?
Ensure brevity in your answer.  2.47. What is the difference between the highest and the lowest Gross enrolment ratio (%) in Pre-primary schools?
Provide a short and direct response. 6.93. What is the difference between the highest and the lowest Gross enrolment ratio (%) of Primary schools?
Give a very brief answer. 9.52. What is the difference between the highest and the lowest Gross enrolment ratio (%) of Secondary schools?
Keep it short and to the point. 5.16. What is the difference between the highest and the lowest Gross enrolment ratio (%) in Tertiary schools?
Your answer should be compact. 10.02. 